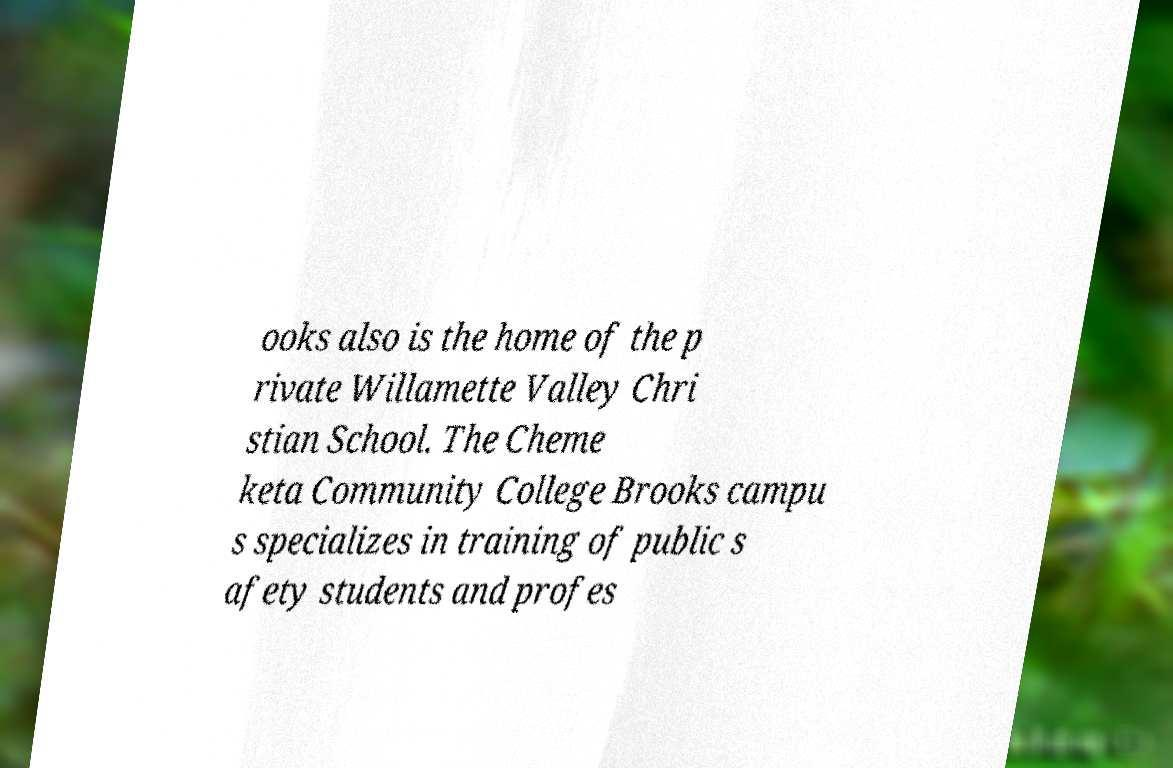Could you extract and type out the text from this image? ooks also is the home of the p rivate Willamette Valley Chri stian School. The Cheme keta Community College Brooks campu s specializes in training of public s afety students and profes 